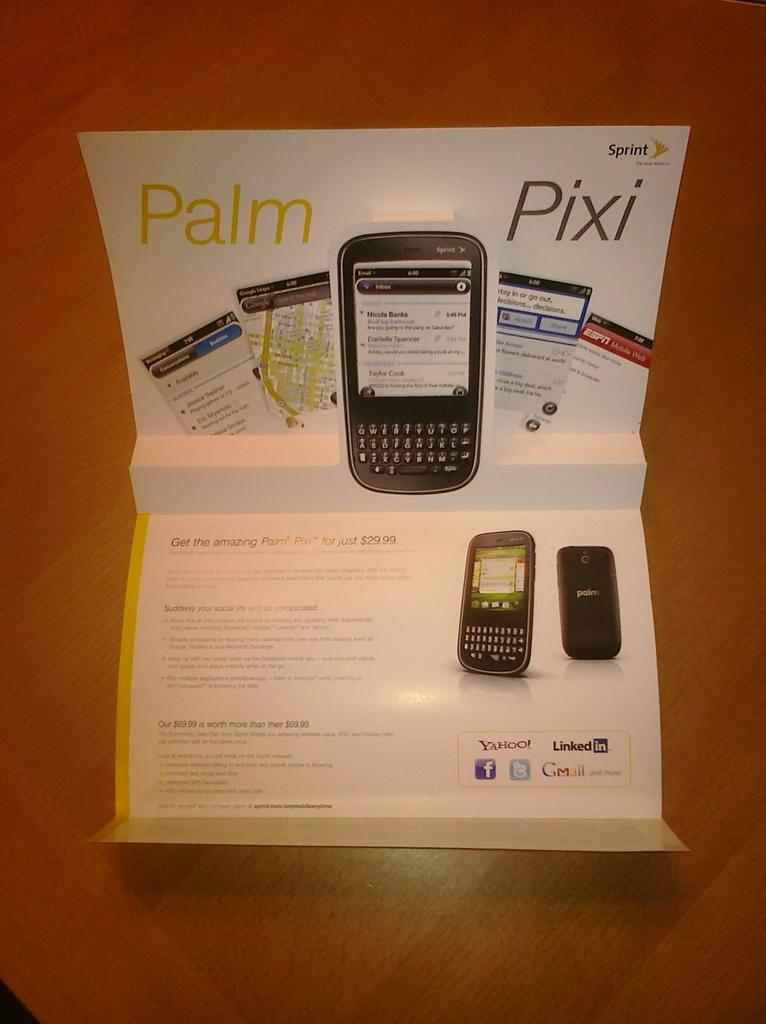<image>
Provide a brief description of the given image. A Palm Pixi sits in a cardboard foldout case. 